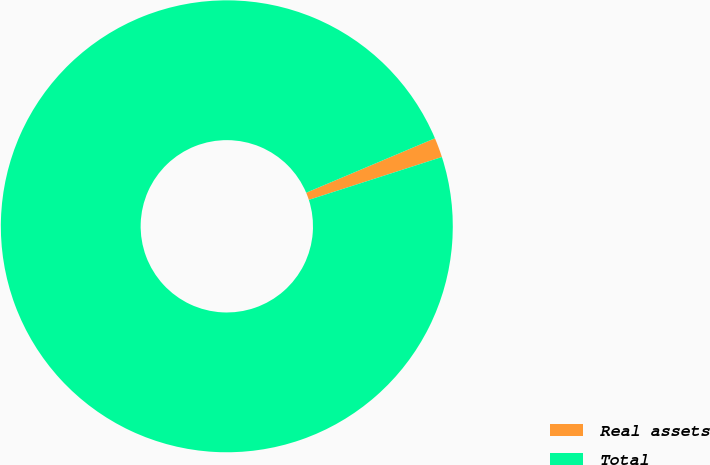<chart> <loc_0><loc_0><loc_500><loc_500><pie_chart><fcel>Real assets<fcel>Total<nl><fcel>1.41%<fcel>98.59%<nl></chart> 